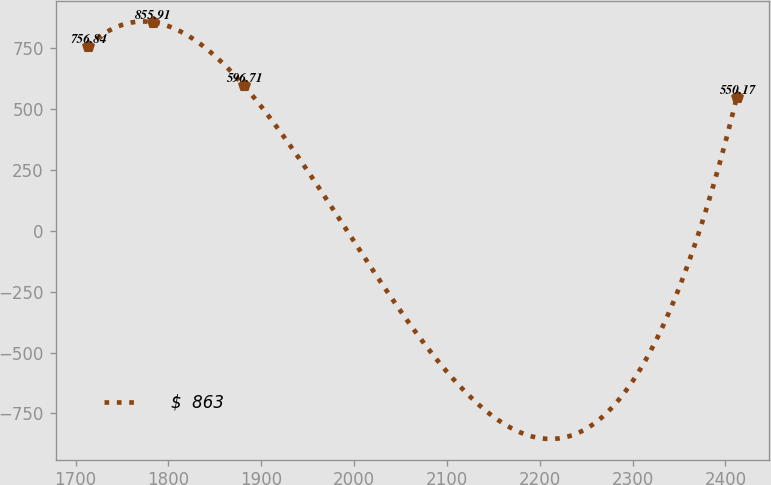<chart> <loc_0><loc_0><loc_500><loc_500><line_chart><ecel><fcel>$  863<nl><fcel>1713.27<fcel>756.84<nl><fcel>1783.18<fcel>855.91<nl><fcel>1880.99<fcel>596.71<nl><fcel>2412.36<fcel>550.17<nl></chart> 